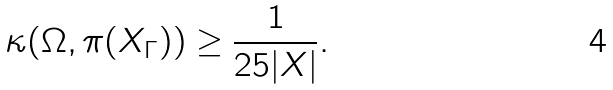<formula> <loc_0><loc_0><loc_500><loc_500>\kappa ( \Omega , \pi ( X _ { \Gamma } ) ) \geq \frac { 1 } { 2 5 | X | } .</formula> 